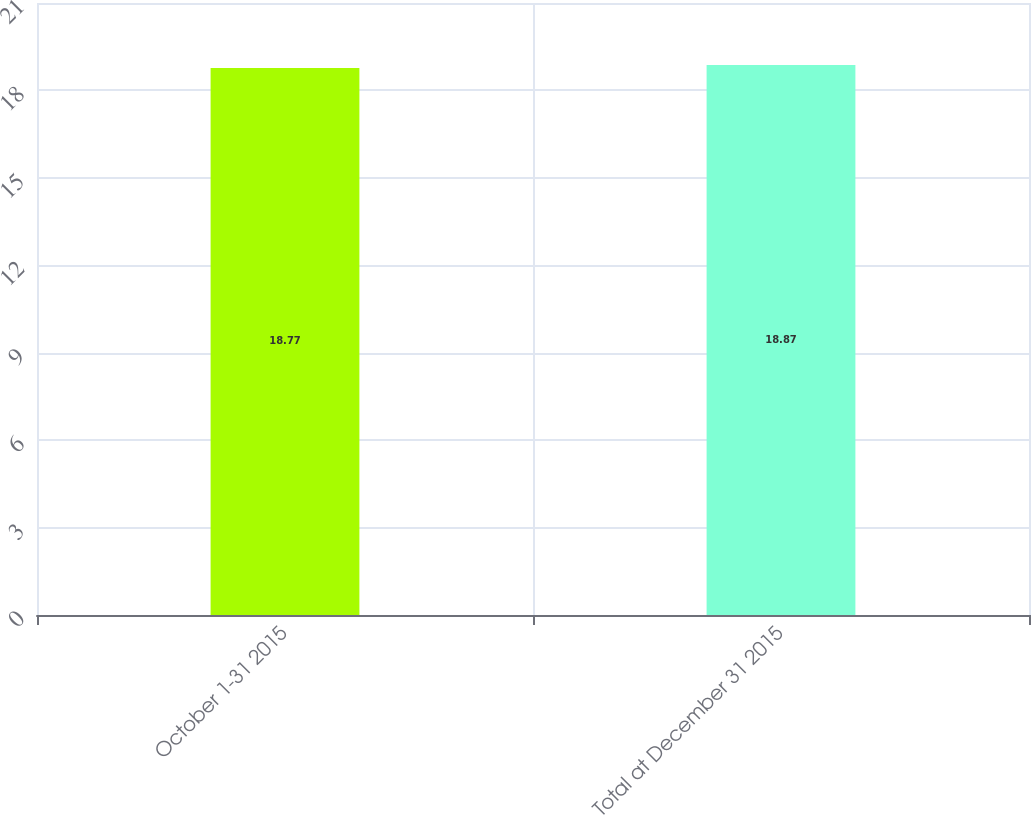Convert chart. <chart><loc_0><loc_0><loc_500><loc_500><bar_chart><fcel>October 1-31 2015<fcel>Total at December 31 2015<nl><fcel>18.77<fcel>18.87<nl></chart> 